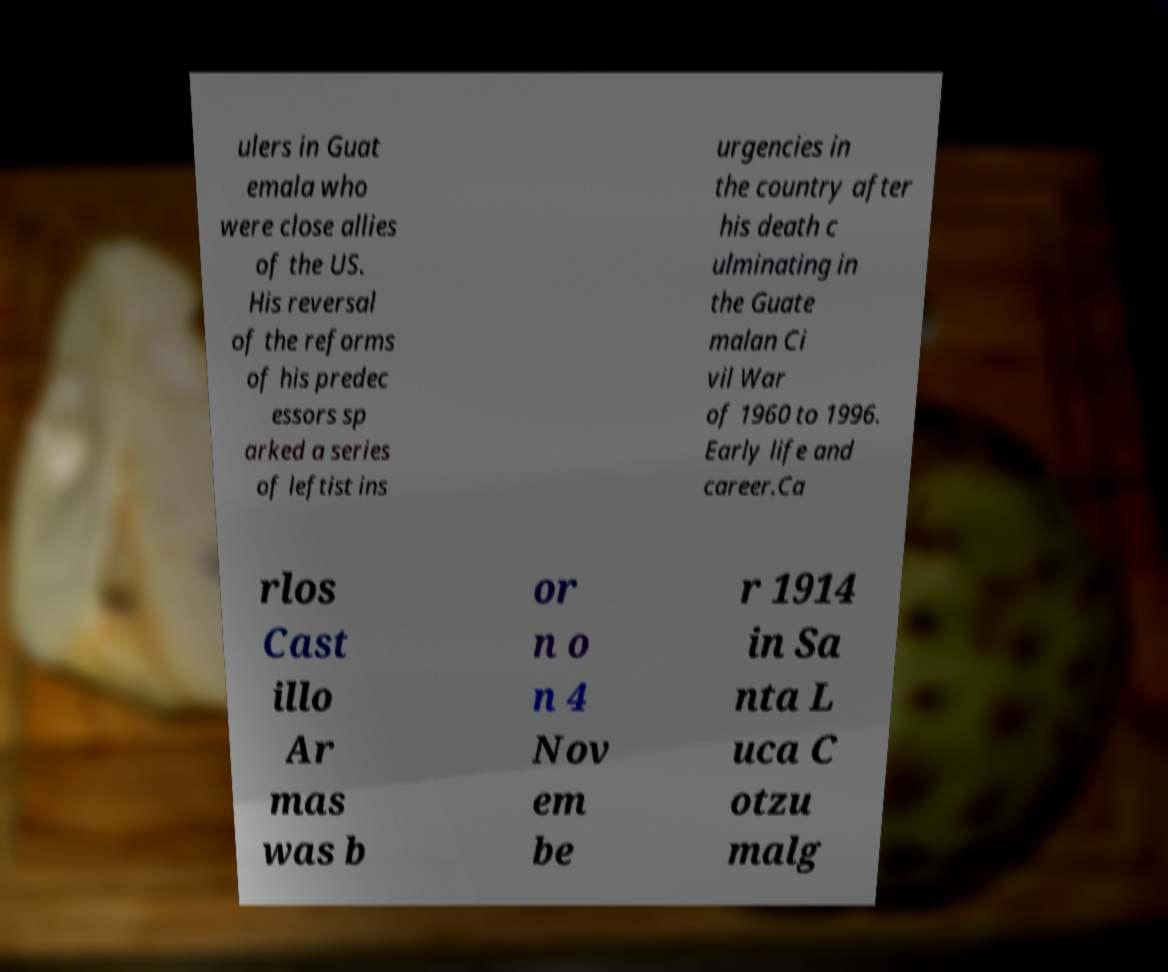Please identify and transcribe the text found in this image. ulers in Guat emala who were close allies of the US. His reversal of the reforms of his predec essors sp arked a series of leftist ins urgencies in the country after his death c ulminating in the Guate malan Ci vil War of 1960 to 1996. Early life and career.Ca rlos Cast illo Ar mas was b or n o n 4 Nov em be r 1914 in Sa nta L uca C otzu malg 